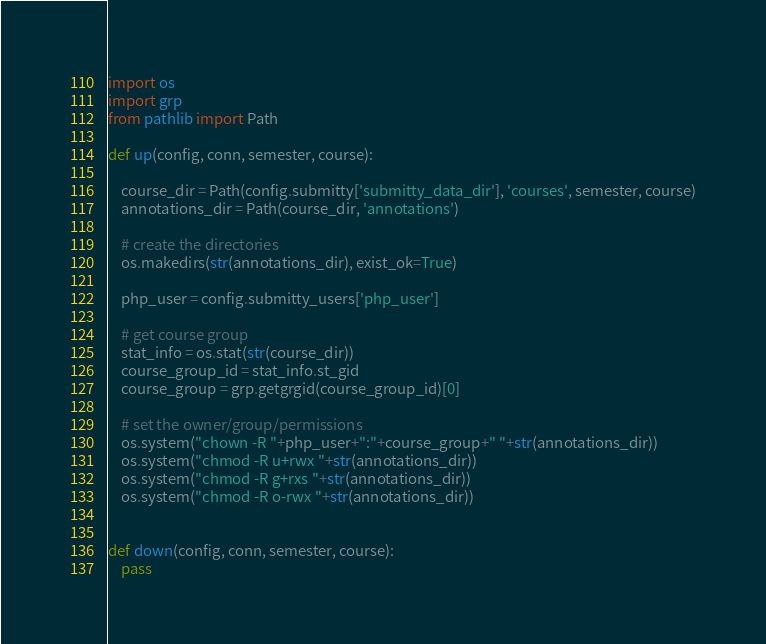Convert code to text. <code><loc_0><loc_0><loc_500><loc_500><_Python_>import os
import grp
from pathlib import Path

def up(config, conn, semester, course):

    course_dir = Path(config.submitty['submitty_data_dir'], 'courses', semester, course)
    annotations_dir = Path(course_dir, 'annotations')

    # create the directories
    os.makedirs(str(annotations_dir), exist_ok=True)

    php_user = config.submitty_users['php_user']

    # get course group
    stat_info = os.stat(str(course_dir))
    course_group_id = stat_info.st_gid
    course_group = grp.getgrgid(course_group_id)[0]

    # set the owner/group/permissions
    os.system("chown -R "+php_user+":"+course_group+" "+str(annotations_dir))
    os.system("chmod -R u+rwx "+str(annotations_dir))
    os.system("chmod -R g+rxs "+str(annotations_dir))
    os.system("chmod -R o-rwx "+str(annotations_dir))

    
def down(config, conn, semester, course):
    pass
</code> 